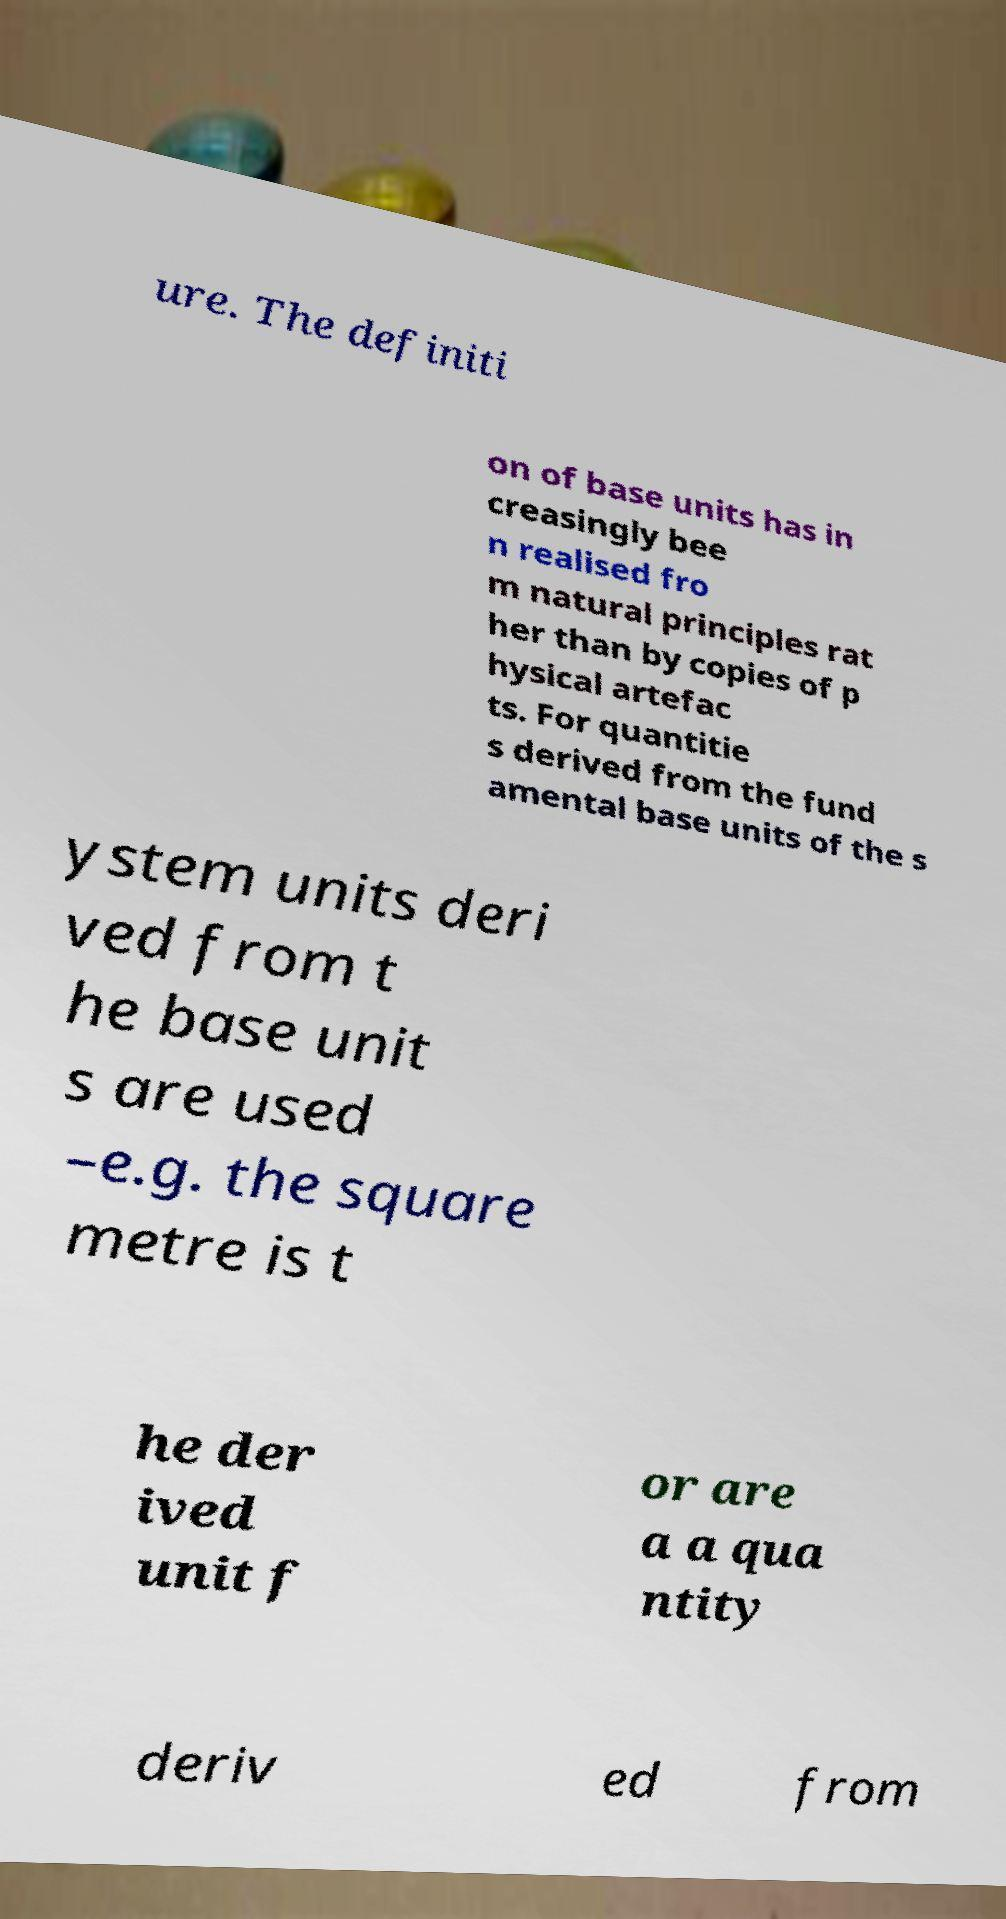Could you assist in decoding the text presented in this image and type it out clearly? ure. The definiti on of base units has in creasingly bee n realised fro m natural principles rat her than by copies of p hysical artefac ts. For quantitie s derived from the fund amental base units of the s ystem units deri ved from t he base unit s are used –e.g. the square metre is t he der ived unit f or are a a qua ntity deriv ed from 